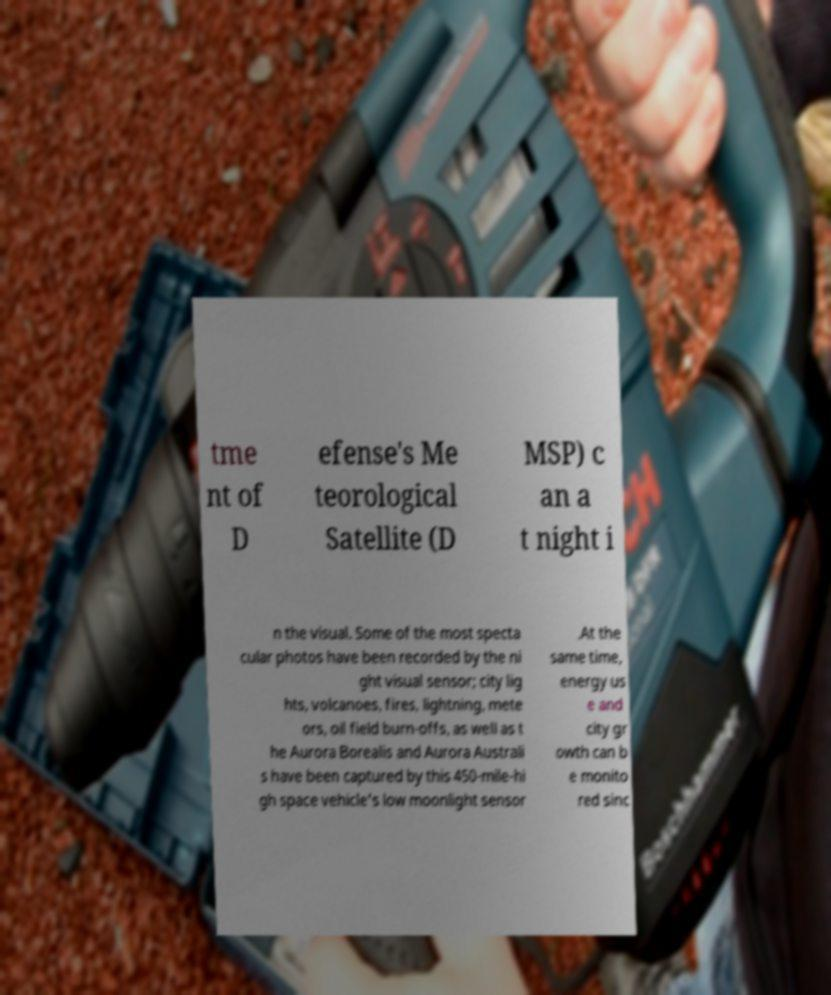For documentation purposes, I need the text within this image transcribed. Could you provide that? tme nt of D efense's Me teorological Satellite (D MSP) c an a t night i n the visual. Some of the most specta cular photos have been recorded by the ni ght visual sensor; city lig hts, volcanoes, fires, lightning, mete ors, oil field burn-offs, as well as t he Aurora Borealis and Aurora Australi s have been captured by this 450-mile-hi gh space vehicle's low moonlight sensor .At the same time, energy us e and city gr owth can b e monito red sinc 